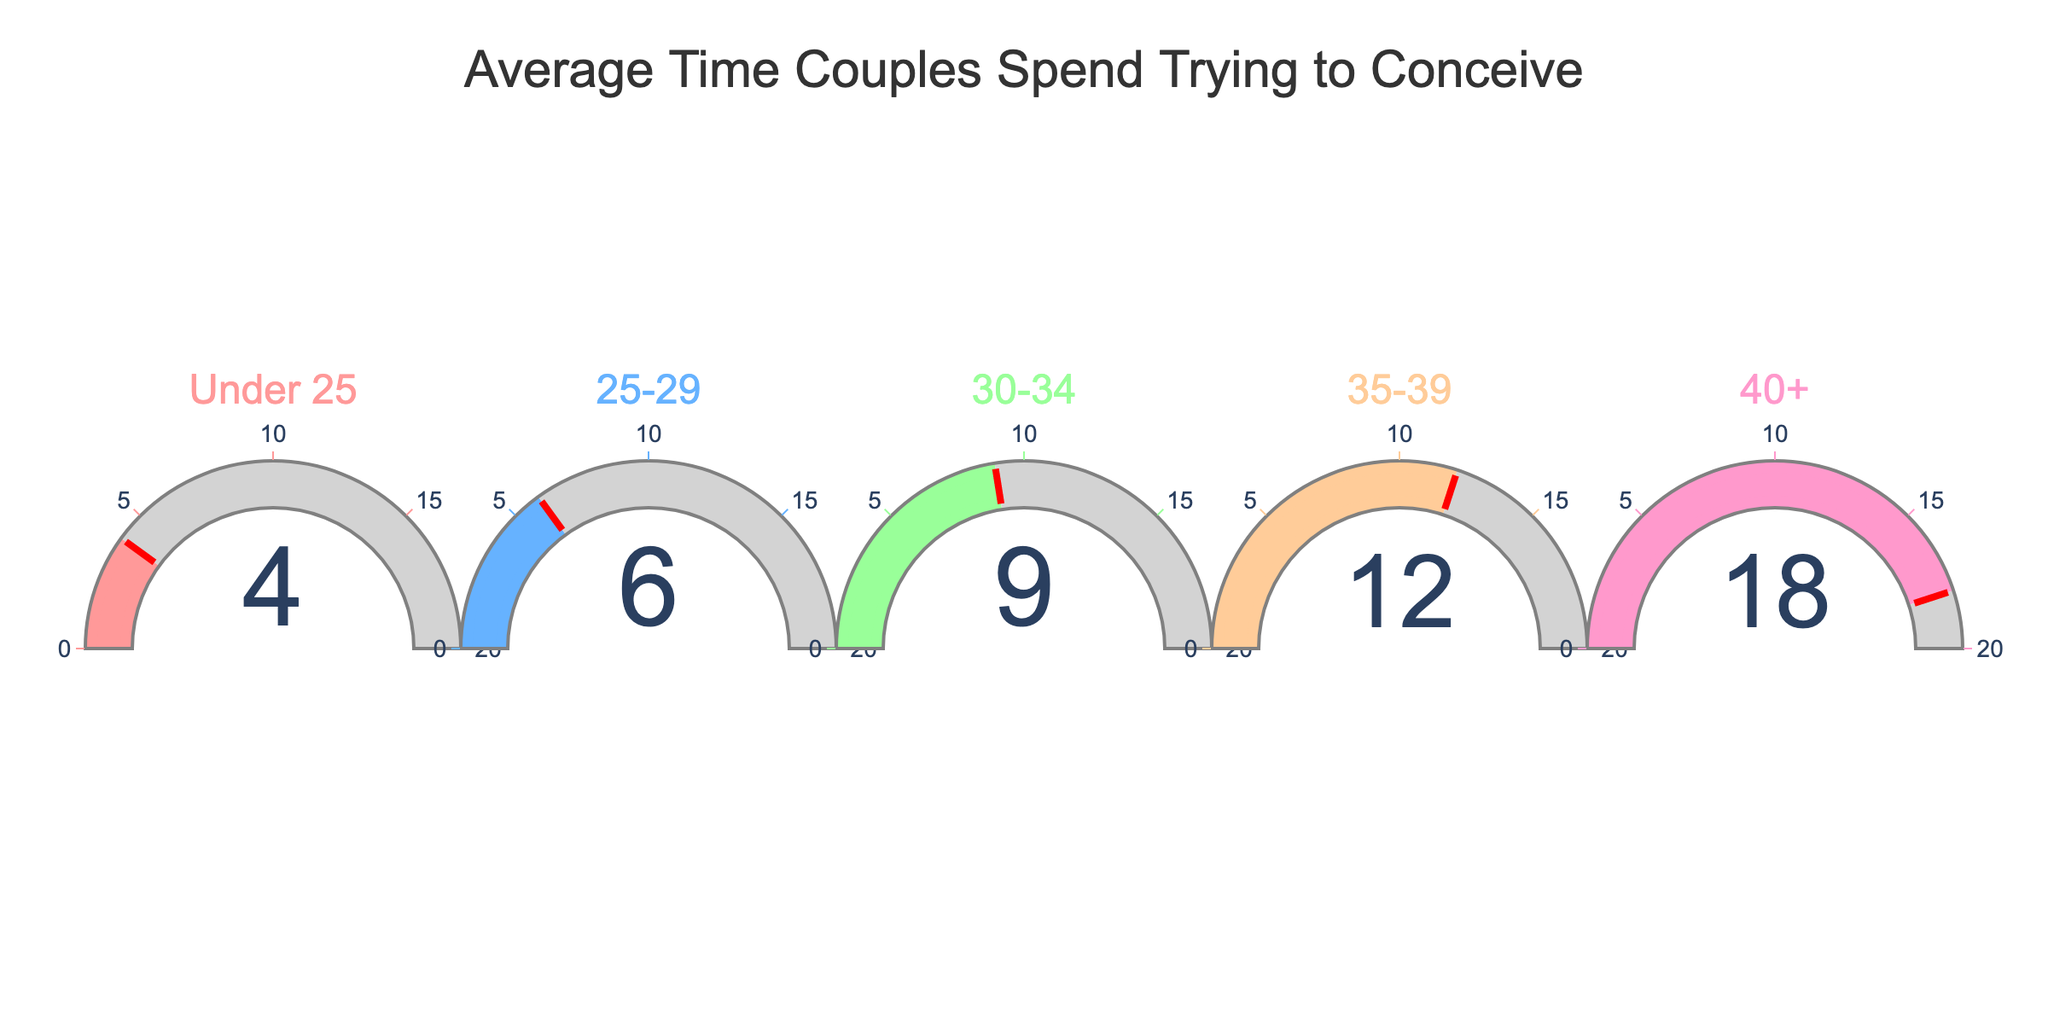What is the average time couples under 25 spend trying to conceive? Locate the gauge chart for the 'Under 25' age group, which shows 4 months.
Answer: 4 months Which age group has the highest average time spent trying to conceive? Find the gauge chart with the highest value, which is the '40+' age group with 18 months.
Answer: 40+ What is the difference in average time trying to conceive between the 25-29 and 35-39 age groups? Identify the values for the 25-29 age group (6 months) and the 35-39 age group (12 months). The difference is 12 - 6.
Answer: 6 months What is the average time trying to conceive for couples aged between 30-34? Locate the gauge chart for the '30-34' age group, which shows 9 months.
Answer: 9 months How does the average time trying to conceive for the 40+ age group compare to the 35-39 age group? The 40+ age group has 18 months, while the 35-39 age group has 12 months. 18 months is more than 12 months.
Answer: More What is the range of the average time trying to conceive across all age groups? The smallest value is 4 months (Under 25) and the largest is 18 months (40+). The range is calculated as 18 - 4.
Answer: 14 months What is the median average time trying to conceive among the age groups? List the values (4, 6, 9, 12, 18). The median value is the middle number in this ordered list.
Answer: 9 months How many of the age groups have an average time over 10 months? Identify the age groups with values over 10 months. These are 35-39 (12 months) and 40+ (18 months), so there are 2 groups.
Answer: 2 How does the average time spent by couples aged under 25 compare to those aged 25-29? The Under 25 age group has 4 months, and the 25-29 age group has 6 months. 4 months is less than 6 months.
Answer: Less Which age group falls between the average times of 25-29 and 35-39 in terms of months spent trying to conceive? Identify the adjacent values for 25-29 (6 months) and 35-39 (12 months). The 30-34 age group has a value of 9 months, which falls between 6 and 12.
Answer: 30-34 